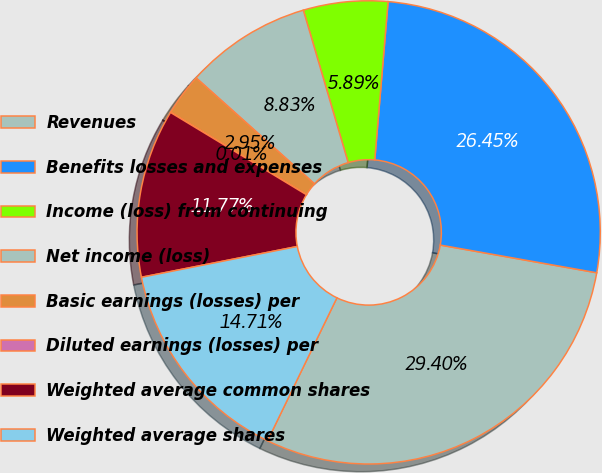<chart> <loc_0><loc_0><loc_500><loc_500><pie_chart><fcel>Revenues<fcel>Benefits losses and expenses<fcel>Income (loss) from continuing<fcel>Net income (loss)<fcel>Basic earnings (losses) per<fcel>Diluted earnings (losses) per<fcel>Weighted average common shares<fcel>Weighted average shares<nl><fcel>29.41%<fcel>26.46%<fcel>5.89%<fcel>8.83%<fcel>2.95%<fcel>0.01%<fcel>11.77%<fcel>14.71%<nl></chart> 